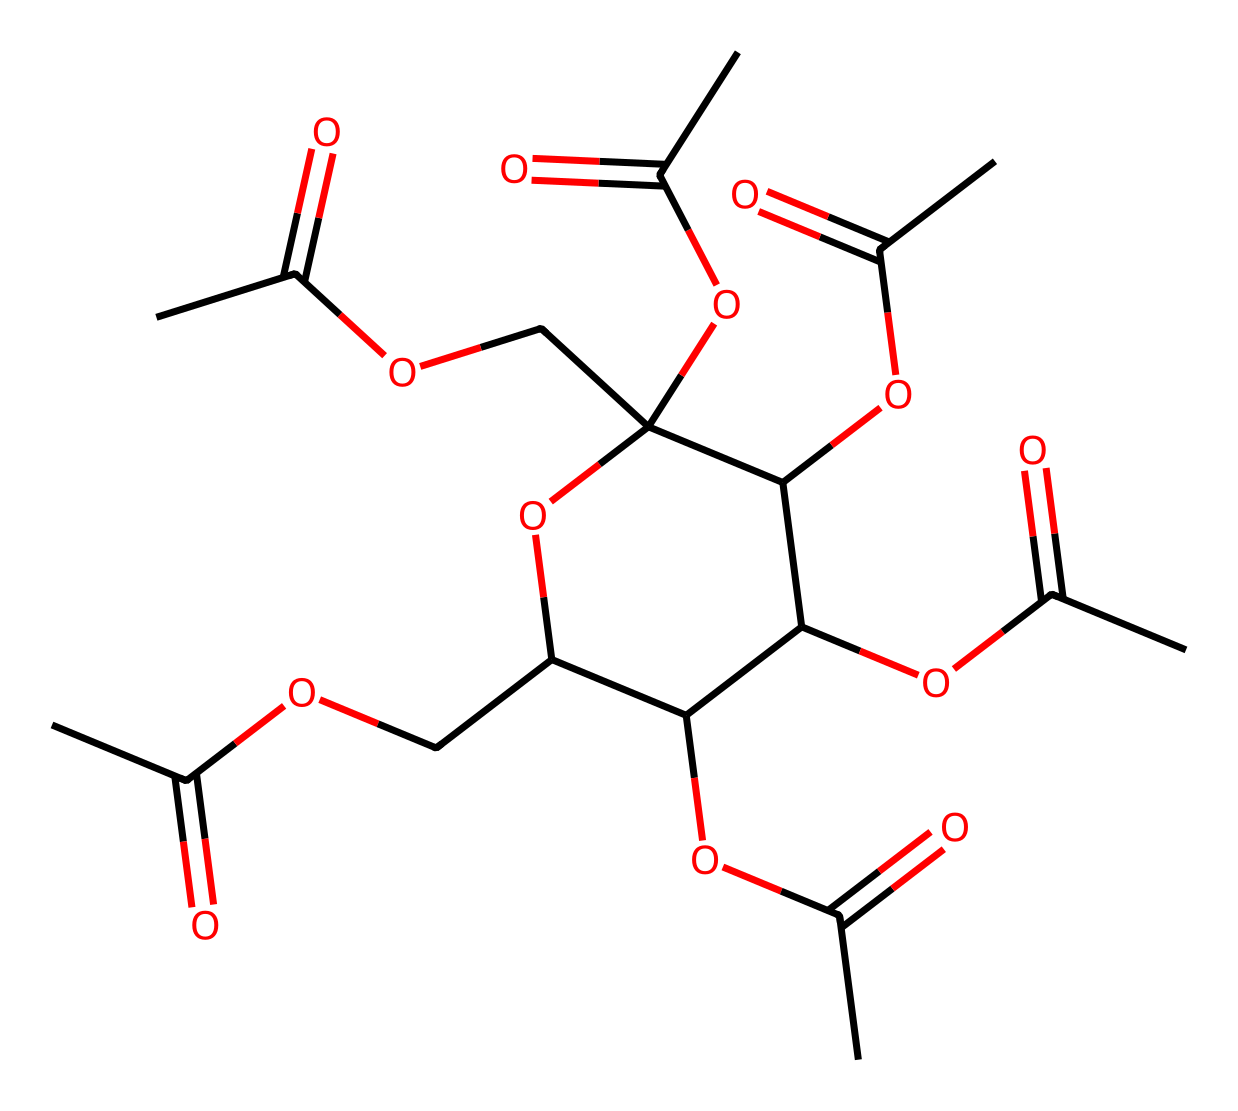What is the total number of carbon atoms in this chemical? By examining the SMILES structure, we can identify each carbon atom present. The structure shows several groups and rings where carbon atoms are part of the ester functional groups and the cyclic structure. Counting the carbon atoms gives a total of 12.
Answer: 12 How many ester functional groups are in this molecule? The structure indicates multiple ester functional groups, which can be identified by the presence of the -COO- linkages in the chemical representation. By analyzing the SMILES, we find five distinct ester groups connected to carbon rings.
Answer: 5 What type of polymer is cellulose acetate classified as? Cellulose acetate is a derivative of cellulose, and due to its long-chain composition formed from repeating units, it is classified as a thermoplastic polymer.
Answer: thermoplastic polymer What physical property is primarily influenced by the acetate groups in this structure? The presence of acetate groups impacts the solubility and flexibility of the cellulose acetate, making it less brittle compared to pure cellulose. These characteristics are key in applications like eyeglass frames.
Answer: solubility What is the role of the ether linkages present in this molecule? The ether linkages, represented by the -O- connections in the structure, provide flexibility and stability to the polymer chain, which affects the overall mechanical properties of cellulose acetate.
Answer: provide flexibility How many oxygen atoms are represented in this structure? The structure contains a total count of the oxygen atoms, which can be identified by counting all the -O- and -CO- groups present in the SMILES representation. This leads to a total of 8 oxygen atoms.
Answer: 8 What characterizes the structure of cellulose acetate that differentiates it from other esters? Cellulose acetate has a unique linear polysaccharide chain formed from repeating glucose units, modified by the addition of acetate groups, distinguishing it from other esters that may not have such a complex structure.
Answer: linear polysaccharide chain 